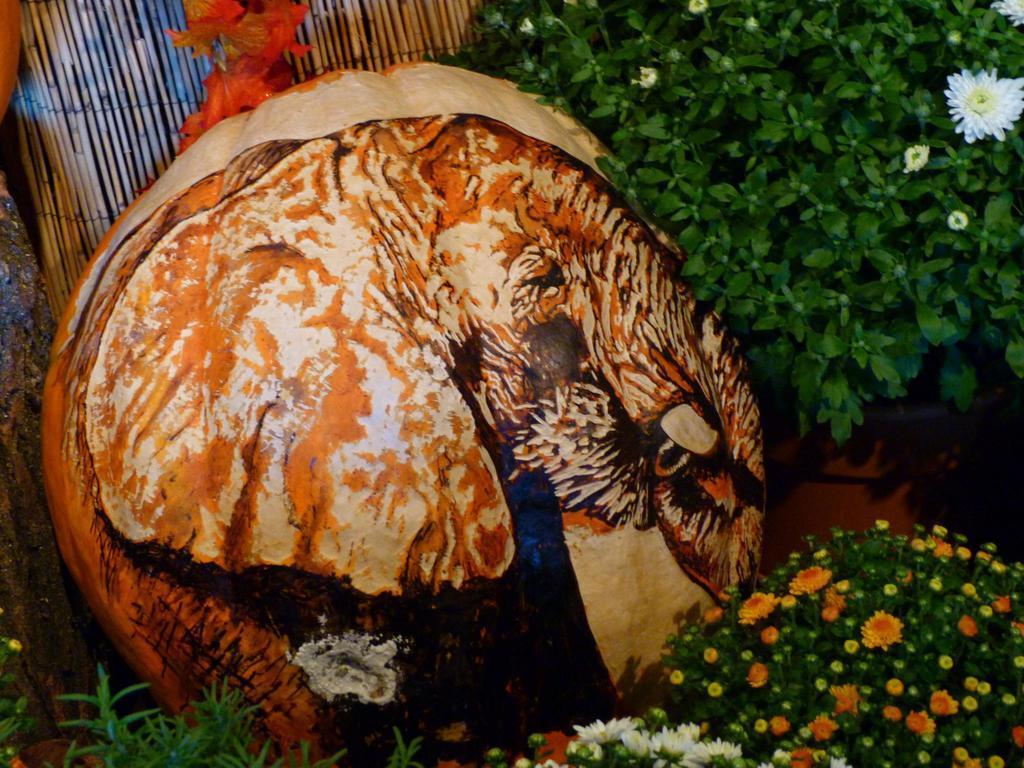In one or two sentences, can you explain what this image depicts? In the foreground of this image, there is painting on a pumpkin like an object around which, there are flowers to the plants. At the top, there is a wooden object and orange color flowers. 